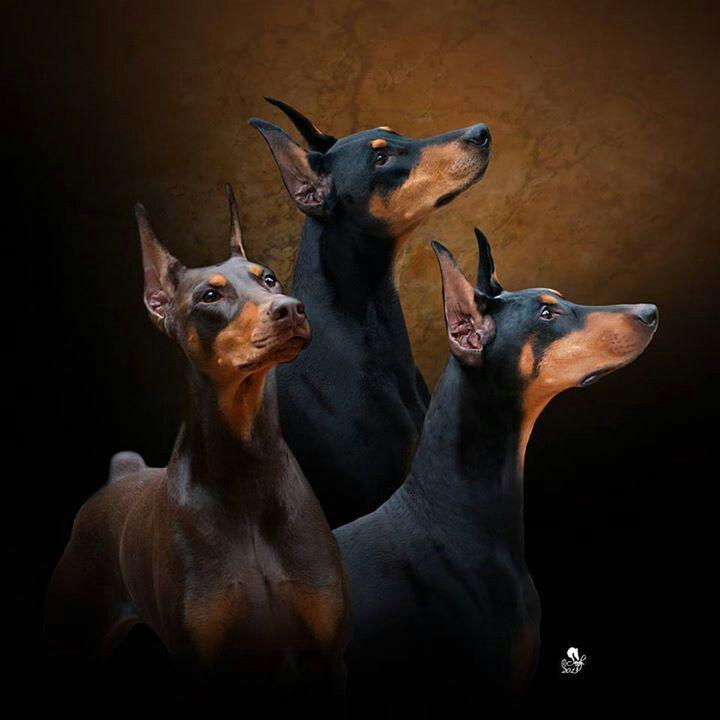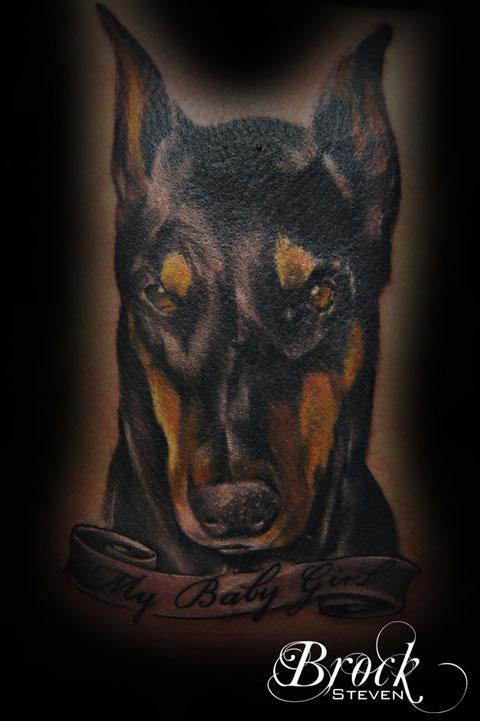The first image is the image on the left, the second image is the image on the right. Considering the images on both sides, is "In both drawings the doberman's mouth is open." valid? Answer yes or no. No. The first image is the image on the left, the second image is the image on the right. Given the left and right images, does the statement "The left and right image contains the same number of dog head tattoos." hold true? Answer yes or no. No. 